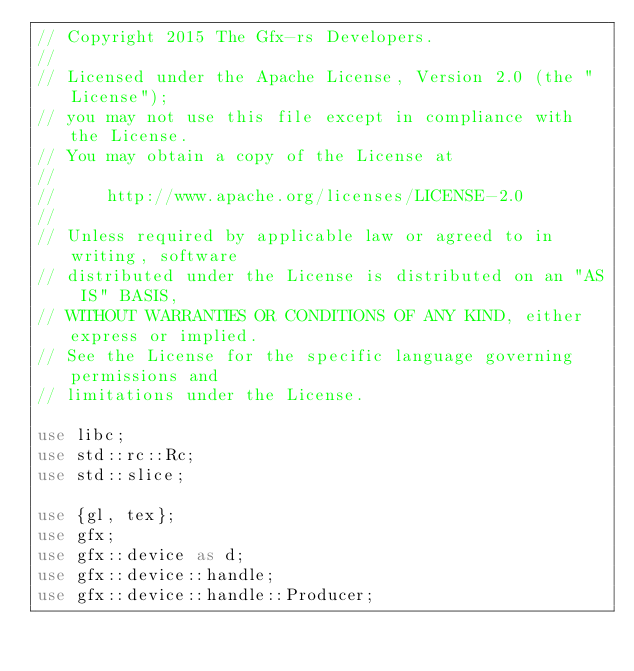<code> <loc_0><loc_0><loc_500><loc_500><_Rust_>// Copyright 2015 The Gfx-rs Developers.
//
// Licensed under the Apache License, Version 2.0 (the "License");
// you may not use this file except in compliance with the License.
// You may obtain a copy of the License at
//
//     http://www.apache.org/licenses/LICENSE-2.0
//
// Unless required by applicable law or agreed to in writing, software
// distributed under the License is distributed on an "AS IS" BASIS,
// WITHOUT WARRANTIES OR CONDITIONS OF ANY KIND, either express or implied.
// See the License for the specific language governing permissions and
// limitations under the License.

use libc;
use std::rc::Rc;
use std::slice;

use {gl, tex};
use gfx;
use gfx::device as d;
use gfx::device::handle;
use gfx::device::handle::Producer;</code> 